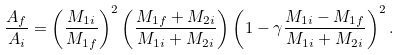Convert formula to latex. <formula><loc_0><loc_0><loc_500><loc_500>\frac { A _ { f } } { A _ { i } } = \left ( \frac { M _ { 1 i } } { M _ { 1 f } } \right ) ^ { 2 } \left ( \frac { M _ { 1 f } + M _ { 2 i } } { M _ { 1 i } + M _ { 2 i } } \right ) \left ( 1 - \gamma \frac { M _ { 1 i } - M _ { 1 f } } { M _ { 1 i } + M _ { 2 i } } \right ) ^ { 2 } .</formula> 